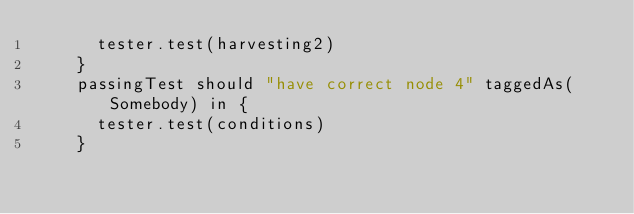<code> <loc_0><loc_0><loc_500><loc_500><_Scala_>      tester.test(harvesting2)
    }
    passingTest should "have correct node 4" taggedAs(Somebody) in {
      tester.test(conditions)
    }
</code> 